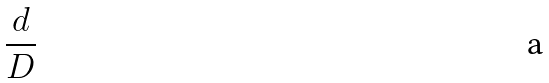<formula> <loc_0><loc_0><loc_500><loc_500>\frac { d } { D }</formula> 